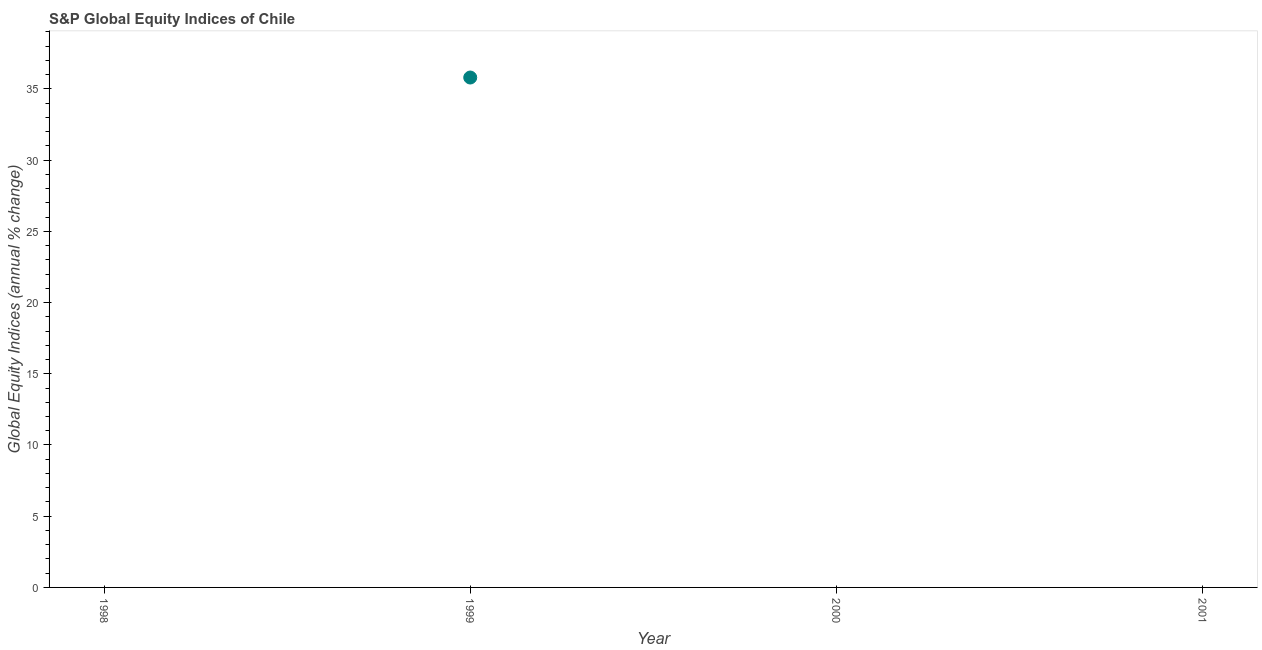What is the s&p global equity indices in 2001?
Keep it short and to the point. 0. Across all years, what is the maximum s&p global equity indices?
Your answer should be very brief. 35.8. In which year was the s&p global equity indices maximum?
Your answer should be compact. 1999. What is the sum of the s&p global equity indices?
Your answer should be very brief. 35.8. What is the average s&p global equity indices per year?
Provide a succinct answer. 8.95. What is the median s&p global equity indices?
Ensure brevity in your answer.  0. In how many years, is the s&p global equity indices greater than 34 %?
Make the answer very short. 1. What is the difference between the highest and the lowest s&p global equity indices?
Make the answer very short. 35.8. In how many years, is the s&p global equity indices greater than the average s&p global equity indices taken over all years?
Make the answer very short. 1. Does the s&p global equity indices monotonically increase over the years?
Ensure brevity in your answer.  No. How many dotlines are there?
Provide a short and direct response. 1. How many years are there in the graph?
Provide a short and direct response. 4. What is the difference between two consecutive major ticks on the Y-axis?
Provide a short and direct response. 5. Does the graph contain any zero values?
Your answer should be very brief. Yes. What is the title of the graph?
Make the answer very short. S&P Global Equity Indices of Chile. What is the label or title of the Y-axis?
Your answer should be compact. Global Equity Indices (annual % change). What is the Global Equity Indices (annual % change) in 1998?
Offer a very short reply. 0. What is the Global Equity Indices (annual % change) in 1999?
Your answer should be very brief. 35.8. 